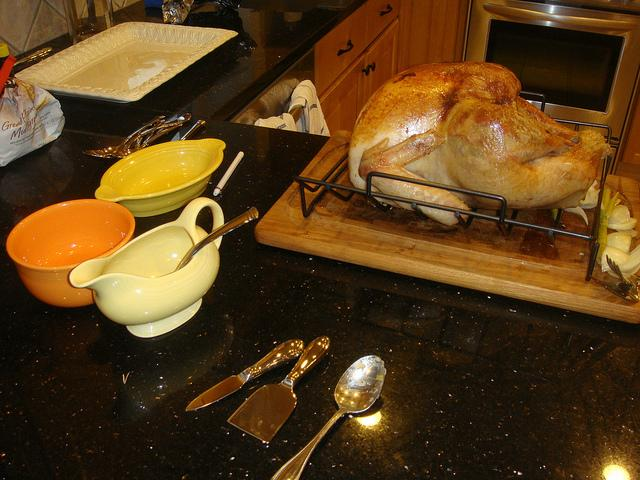What type of animal is being prepared?

Choices:
A) cat
B) bird
C) dog
D) horse bird 